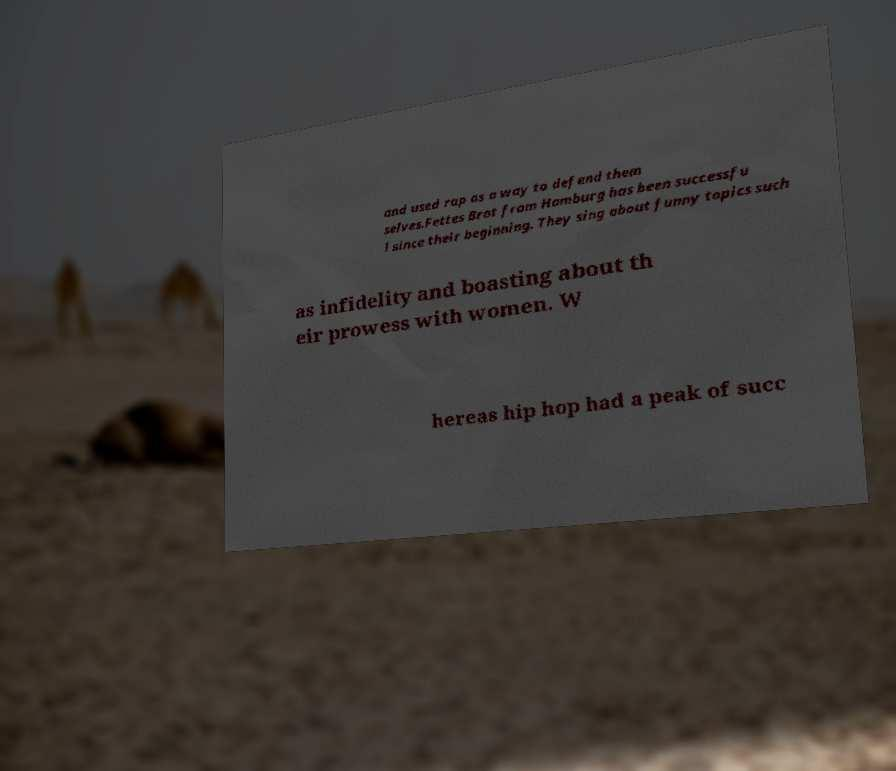For documentation purposes, I need the text within this image transcribed. Could you provide that? and used rap as a way to defend them selves.Fettes Brot from Hamburg has been successfu l since their beginning. They sing about funny topics such as infidelity and boasting about th eir prowess with women. W hereas hip hop had a peak of succ 